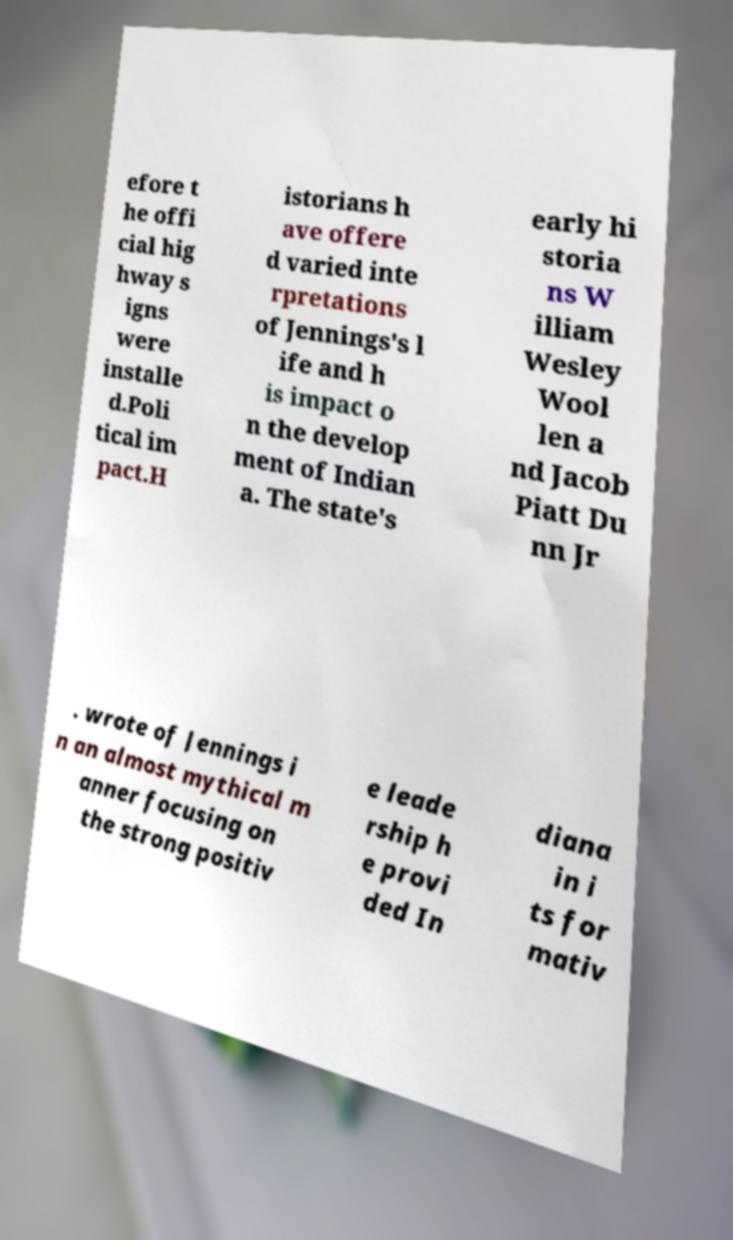Please read and relay the text visible in this image. What does it say? efore t he offi cial hig hway s igns were installe d.Poli tical im pact.H istorians h ave offere d varied inte rpretations of Jennings's l ife and h is impact o n the develop ment of Indian a. The state's early hi storia ns W illiam Wesley Wool len a nd Jacob Piatt Du nn Jr . wrote of Jennings i n an almost mythical m anner focusing on the strong positiv e leade rship h e provi ded In diana in i ts for mativ 